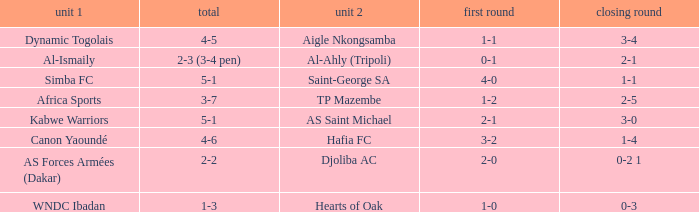What team played against Al-Ismaily (team 1)? Al-Ahly (Tripoli). 